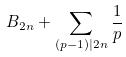<formula> <loc_0><loc_0><loc_500><loc_500>B _ { 2 n } + \sum _ { ( p - 1 ) | 2 n } \frac { 1 } { p }</formula> 